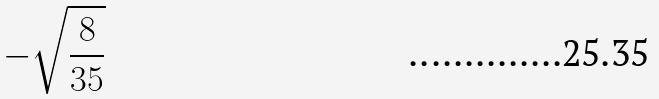Convert formula to latex. <formula><loc_0><loc_0><loc_500><loc_500>- \sqrt { \frac { 8 } { 3 5 } }</formula> 